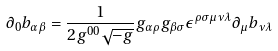<formula> <loc_0><loc_0><loc_500><loc_500>\partial _ { 0 } b _ { \alpha \beta } = \frac { 1 } { 2 g ^ { 0 0 } \sqrt { - g } } g _ { \alpha \rho } g _ { \beta \sigma } \epsilon ^ { \rho \sigma \mu \nu \lambda } \partial _ { \mu } b _ { \nu \lambda }</formula> 